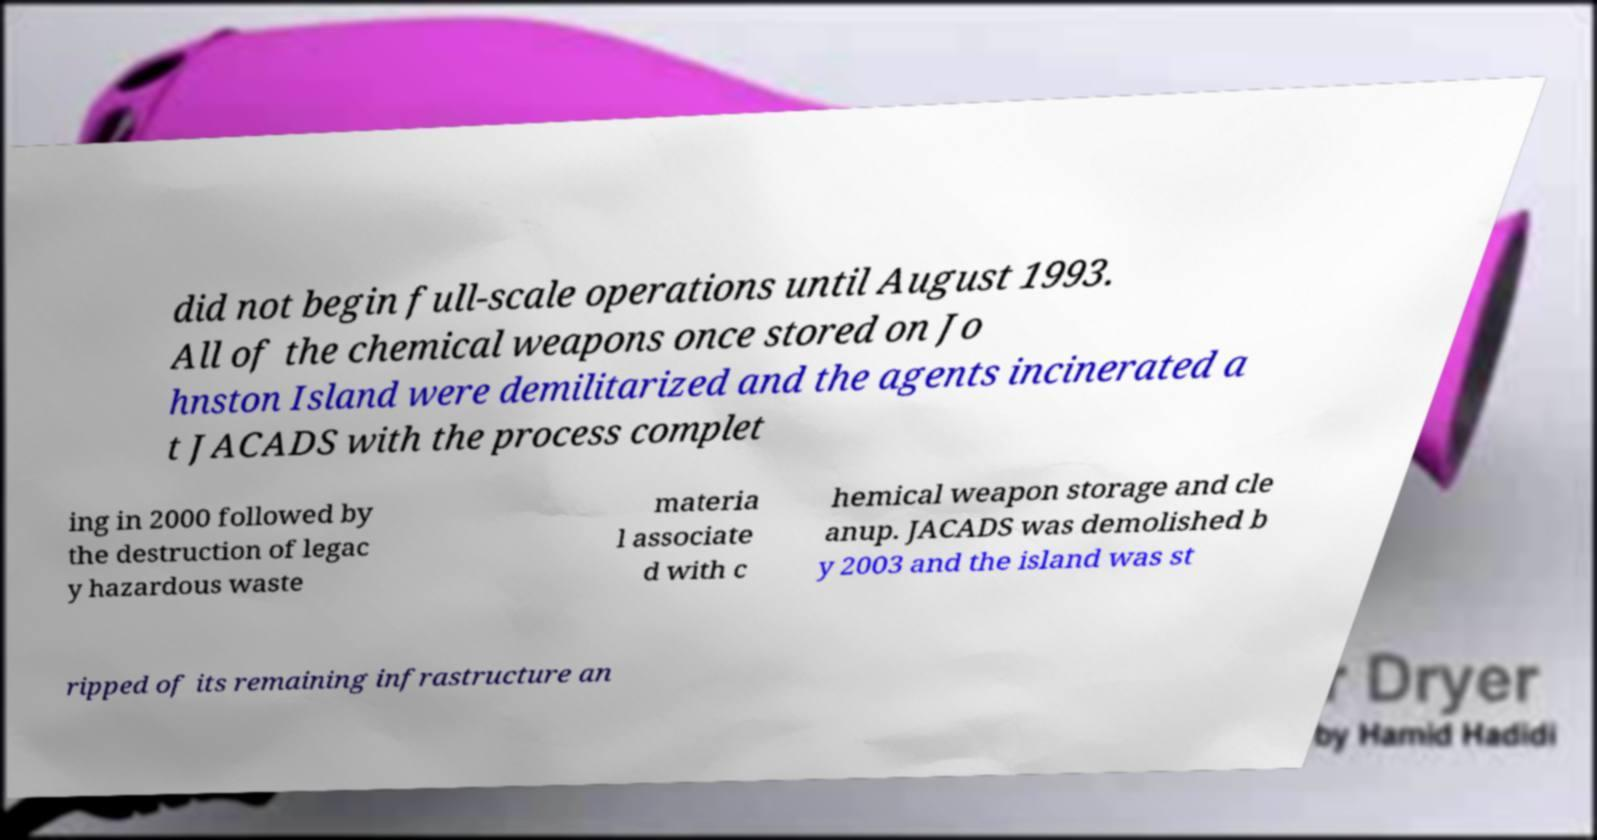For documentation purposes, I need the text within this image transcribed. Could you provide that? did not begin full-scale operations until August 1993. All of the chemical weapons once stored on Jo hnston Island were demilitarized and the agents incinerated a t JACADS with the process complet ing in 2000 followed by the destruction of legac y hazardous waste materia l associate d with c hemical weapon storage and cle anup. JACADS was demolished b y 2003 and the island was st ripped of its remaining infrastructure an 